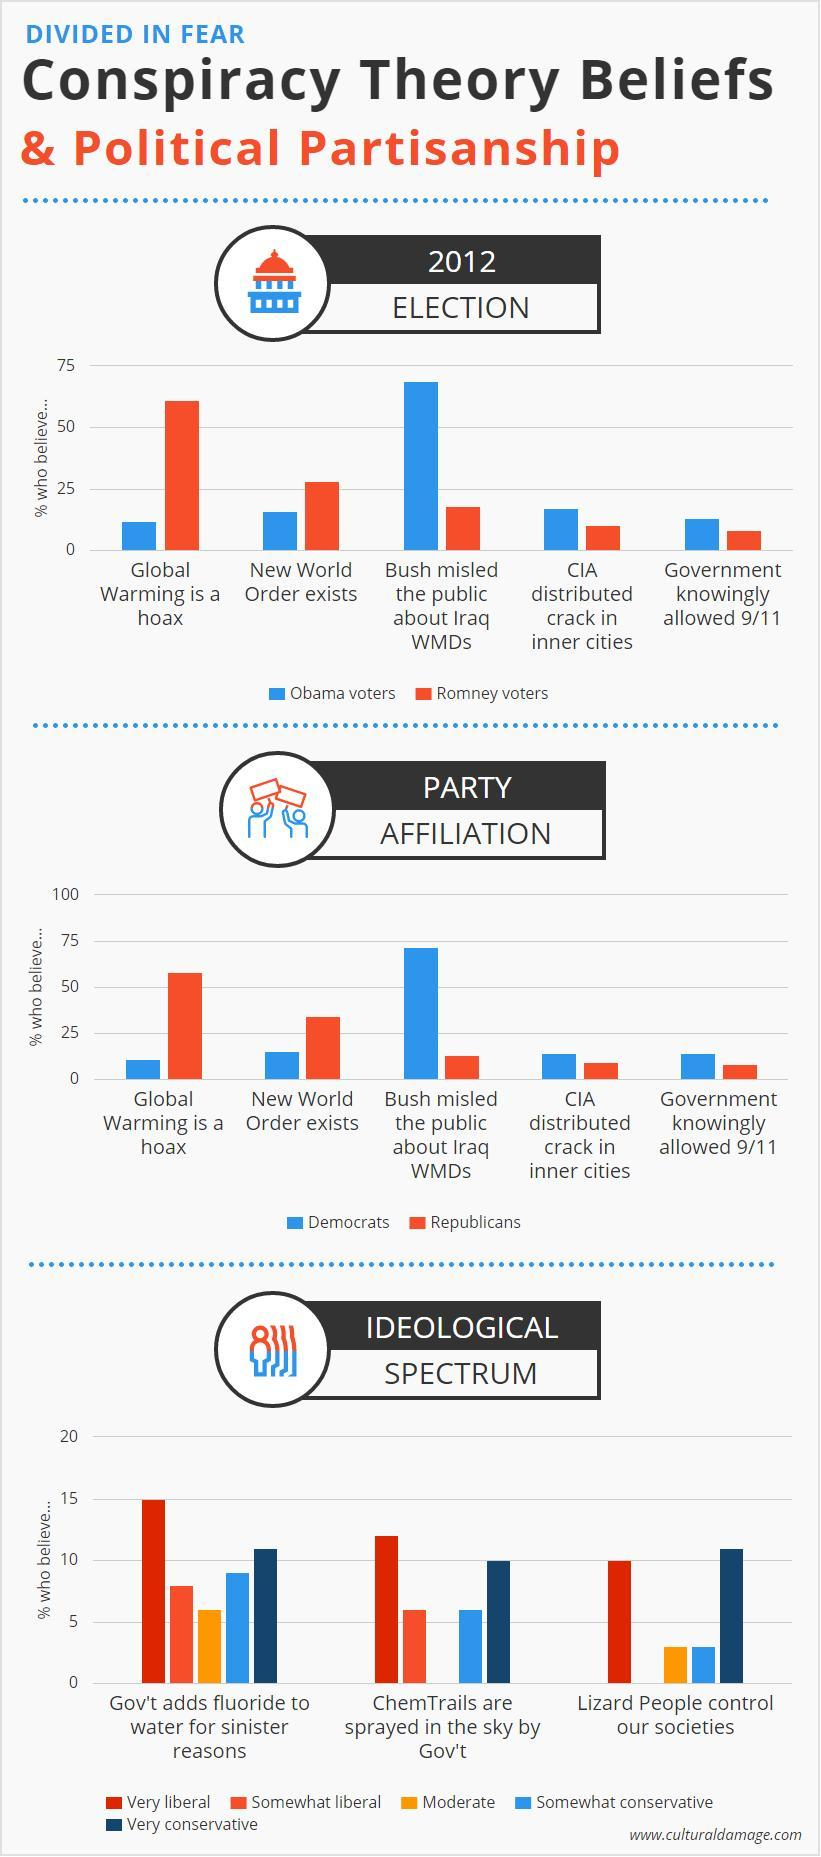10% of which ideology believe that lizard people control our societies?
Answer the question with a short phrase. Very liberal Who doesn't believe that lizard people control our societies? Somewhat liberal What percent of very conservative people believe that chemtrails are sprayed in the sky by the Govt? 10% What percent of very liberal people believe that Govt adds fluoride to water? 15% Above 50% of who believe that global warming is a hoax? Romney voters 